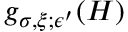<formula> <loc_0><loc_0><loc_500><loc_500>g _ { \sigma , \xi ; \epsilon ^ { \prime } } ( H )</formula> 